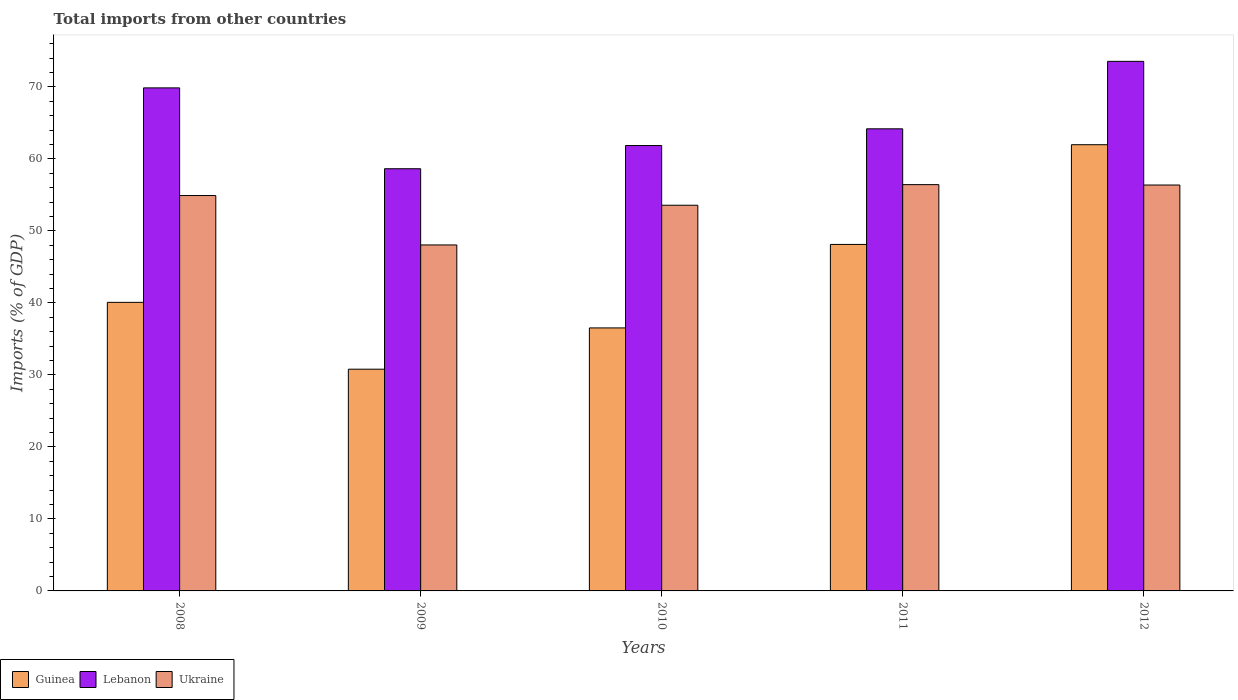How many different coloured bars are there?
Your answer should be very brief. 3. How many groups of bars are there?
Provide a short and direct response. 5. How many bars are there on the 4th tick from the right?
Give a very brief answer. 3. What is the label of the 5th group of bars from the left?
Give a very brief answer. 2012. In how many cases, is the number of bars for a given year not equal to the number of legend labels?
Keep it short and to the point. 0. What is the total imports in Lebanon in 2011?
Give a very brief answer. 64.18. Across all years, what is the maximum total imports in Guinea?
Your answer should be very brief. 61.97. Across all years, what is the minimum total imports in Guinea?
Your answer should be compact. 30.79. What is the total total imports in Guinea in the graph?
Your response must be concise. 217.49. What is the difference between the total imports in Guinea in 2008 and that in 2011?
Provide a succinct answer. -8.05. What is the difference between the total imports in Guinea in 2010 and the total imports in Lebanon in 2012?
Offer a very short reply. -37.02. What is the average total imports in Lebanon per year?
Keep it short and to the point. 65.62. In the year 2008, what is the difference between the total imports in Ukraine and total imports in Lebanon?
Your answer should be very brief. -14.95. In how many years, is the total imports in Ukraine greater than 58 %?
Your response must be concise. 0. What is the ratio of the total imports in Lebanon in 2009 to that in 2011?
Your answer should be very brief. 0.91. Is the difference between the total imports in Ukraine in 2009 and 2010 greater than the difference between the total imports in Lebanon in 2009 and 2010?
Your answer should be compact. No. What is the difference between the highest and the second highest total imports in Lebanon?
Ensure brevity in your answer.  3.69. What is the difference between the highest and the lowest total imports in Ukraine?
Your response must be concise. 8.38. In how many years, is the total imports in Ukraine greater than the average total imports in Ukraine taken over all years?
Provide a succinct answer. 3. What does the 3rd bar from the left in 2010 represents?
Your response must be concise. Ukraine. What does the 2nd bar from the right in 2009 represents?
Make the answer very short. Lebanon. Is it the case that in every year, the sum of the total imports in Lebanon and total imports in Ukraine is greater than the total imports in Guinea?
Provide a short and direct response. Yes. How many bars are there?
Your answer should be very brief. 15. Are all the bars in the graph horizontal?
Keep it short and to the point. No. Does the graph contain any zero values?
Make the answer very short. No. Does the graph contain grids?
Offer a very short reply. No. What is the title of the graph?
Offer a terse response. Total imports from other countries. What is the label or title of the X-axis?
Make the answer very short. Years. What is the label or title of the Y-axis?
Keep it short and to the point. Imports (% of GDP). What is the Imports (% of GDP) in Guinea in 2008?
Keep it short and to the point. 40.08. What is the Imports (% of GDP) in Lebanon in 2008?
Offer a very short reply. 69.86. What is the Imports (% of GDP) of Ukraine in 2008?
Keep it short and to the point. 54.91. What is the Imports (% of GDP) of Guinea in 2009?
Provide a succinct answer. 30.79. What is the Imports (% of GDP) of Lebanon in 2009?
Offer a very short reply. 58.63. What is the Imports (% of GDP) in Ukraine in 2009?
Keep it short and to the point. 48.05. What is the Imports (% of GDP) in Guinea in 2010?
Make the answer very short. 36.53. What is the Imports (% of GDP) of Lebanon in 2010?
Make the answer very short. 61.86. What is the Imports (% of GDP) in Ukraine in 2010?
Offer a terse response. 53.56. What is the Imports (% of GDP) of Guinea in 2011?
Make the answer very short. 48.12. What is the Imports (% of GDP) in Lebanon in 2011?
Ensure brevity in your answer.  64.18. What is the Imports (% of GDP) in Ukraine in 2011?
Your response must be concise. 56.43. What is the Imports (% of GDP) in Guinea in 2012?
Provide a short and direct response. 61.97. What is the Imports (% of GDP) in Lebanon in 2012?
Your answer should be compact. 73.55. What is the Imports (% of GDP) of Ukraine in 2012?
Give a very brief answer. 56.37. Across all years, what is the maximum Imports (% of GDP) of Guinea?
Your response must be concise. 61.97. Across all years, what is the maximum Imports (% of GDP) in Lebanon?
Keep it short and to the point. 73.55. Across all years, what is the maximum Imports (% of GDP) of Ukraine?
Your answer should be compact. 56.43. Across all years, what is the minimum Imports (% of GDP) in Guinea?
Keep it short and to the point. 30.79. Across all years, what is the minimum Imports (% of GDP) in Lebanon?
Ensure brevity in your answer.  58.63. Across all years, what is the minimum Imports (% of GDP) in Ukraine?
Offer a very short reply. 48.05. What is the total Imports (% of GDP) of Guinea in the graph?
Offer a terse response. 217.49. What is the total Imports (% of GDP) in Lebanon in the graph?
Give a very brief answer. 328.08. What is the total Imports (% of GDP) in Ukraine in the graph?
Provide a short and direct response. 269.32. What is the difference between the Imports (% of GDP) of Guinea in 2008 and that in 2009?
Your answer should be compact. 9.28. What is the difference between the Imports (% of GDP) in Lebanon in 2008 and that in 2009?
Your answer should be compact. 11.23. What is the difference between the Imports (% of GDP) in Ukraine in 2008 and that in 2009?
Your response must be concise. 6.86. What is the difference between the Imports (% of GDP) of Guinea in 2008 and that in 2010?
Give a very brief answer. 3.55. What is the difference between the Imports (% of GDP) in Lebanon in 2008 and that in 2010?
Your answer should be compact. 8.01. What is the difference between the Imports (% of GDP) in Ukraine in 2008 and that in 2010?
Your response must be concise. 1.35. What is the difference between the Imports (% of GDP) of Guinea in 2008 and that in 2011?
Your answer should be very brief. -8.05. What is the difference between the Imports (% of GDP) of Lebanon in 2008 and that in 2011?
Offer a very short reply. 5.68. What is the difference between the Imports (% of GDP) in Ukraine in 2008 and that in 2011?
Offer a very short reply. -1.51. What is the difference between the Imports (% of GDP) in Guinea in 2008 and that in 2012?
Provide a short and direct response. -21.89. What is the difference between the Imports (% of GDP) of Lebanon in 2008 and that in 2012?
Offer a terse response. -3.69. What is the difference between the Imports (% of GDP) of Ukraine in 2008 and that in 2012?
Your answer should be very brief. -1.46. What is the difference between the Imports (% of GDP) of Guinea in 2009 and that in 2010?
Your answer should be very brief. -5.73. What is the difference between the Imports (% of GDP) of Lebanon in 2009 and that in 2010?
Provide a short and direct response. -3.22. What is the difference between the Imports (% of GDP) in Ukraine in 2009 and that in 2010?
Your response must be concise. -5.51. What is the difference between the Imports (% of GDP) in Guinea in 2009 and that in 2011?
Provide a short and direct response. -17.33. What is the difference between the Imports (% of GDP) in Lebanon in 2009 and that in 2011?
Make the answer very short. -5.54. What is the difference between the Imports (% of GDP) in Ukraine in 2009 and that in 2011?
Offer a terse response. -8.38. What is the difference between the Imports (% of GDP) in Guinea in 2009 and that in 2012?
Provide a short and direct response. -31.18. What is the difference between the Imports (% of GDP) of Lebanon in 2009 and that in 2012?
Offer a terse response. -14.91. What is the difference between the Imports (% of GDP) of Ukraine in 2009 and that in 2012?
Make the answer very short. -8.32. What is the difference between the Imports (% of GDP) in Guinea in 2010 and that in 2011?
Keep it short and to the point. -11.59. What is the difference between the Imports (% of GDP) of Lebanon in 2010 and that in 2011?
Your answer should be compact. -2.32. What is the difference between the Imports (% of GDP) of Ukraine in 2010 and that in 2011?
Keep it short and to the point. -2.86. What is the difference between the Imports (% of GDP) of Guinea in 2010 and that in 2012?
Keep it short and to the point. -25.44. What is the difference between the Imports (% of GDP) in Lebanon in 2010 and that in 2012?
Provide a short and direct response. -11.69. What is the difference between the Imports (% of GDP) in Ukraine in 2010 and that in 2012?
Provide a succinct answer. -2.81. What is the difference between the Imports (% of GDP) in Guinea in 2011 and that in 2012?
Provide a succinct answer. -13.85. What is the difference between the Imports (% of GDP) in Lebanon in 2011 and that in 2012?
Your answer should be compact. -9.37. What is the difference between the Imports (% of GDP) of Ukraine in 2011 and that in 2012?
Offer a terse response. 0.05. What is the difference between the Imports (% of GDP) of Guinea in 2008 and the Imports (% of GDP) of Lebanon in 2009?
Offer a very short reply. -18.56. What is the difference between the Imports (% of GDP) in Guinea in 2008 and the Imports (% of GDP) in Ukraine in 2009?
Your answer should be very brief. -7.97. What is the difference between the Imports (% of GDP) of Lebanon in 2008 and the Imports (% of GDP) of Ukraine in 2009?
Make the answer very short. 21.81. What is the difference between the Imports (% of GDP) in Guinea in 2008 and the Imports (% of GDP) in Lebanon in 2010?
Provide a short and direct response. -21.78. What is the difference between the Imports (% of GDP) of Guinea in 2008 and the Imports (% of GDP) of Ukraine in 2010?
Your answer should be compact. -13.49. What is the difference between the Imports (% of GDP) in Lebanon in 2008 and the Imports (% of GDP) in Ukraine in 2010?
Your answer should be compact. 16.3. What is the difference between the Imports (% of GDP) in Guinea in 2008 and the Imports (% of GDP) in Lebanon in 2011?
Offer a very short reply. -24.1. What is the difference between the Imports (% of GDP) in Guinea in 2008 and the Imports (% of GDP) in Ukraine in 2011?
Give a very brief answer. -16.35. What is the difference between the Imports (% of GDP) of Lebanon in 2008 and the Imports (% of GDP) of Ukraine in 2011?
Give a very brief answer. 13.44. What is the difference between the Imports (% of GDP) of Guinea in 2008 and the Imports (% of GDP) of Lebanon in 2012?
Keep it short and to the point. -33.47. What is the difference between the Imports (% of GDP) in Guinea in 2008 and the Imports (% of GDP) in Ukraine in 2012?
Your response must be concise. -16.3. What is the difference between the Imports (% of GDP) of Lebanon in 2008 and the Imports (% of GDP) of Ukraine in 2012?
Your response must be concise. 13.49. What is the difference between the Imports (% of GDP) of Guinea in 2009 and the Imports (% of GDP) of Lebanon in 2010?
Provide a short and direct response. -31.06. What is the difference between the Imports (% of GDP) of Guinea in 2009 and the Imports (% of GDP) of Ukraine in 2010?
Your response must be concise. -22.77. What is the difference between the Imports (% of GDP) in Lebanon in 2009 and the Imports (% of GDP) in Ukraine in 2010?
Ensure brevity in your answer.  5.07. What is the difference between the Imports (% of GDP) of Guinea in 2009 and the Imports (% of GDP) of Lebanon in 2011?
Give a very brief answer. -33.39. What is the difference between the Imports (% of GDP) in Guinea in 2009 and the Imports (% of GDP) in Ukraine in 2011?
Offer a very short reply. -25.63. What is the difference between the Imports (% of GDP) in Lebanon in 2009 and the Imports (% of GDP) in Ukraine in 2011?
Provide a short and direct response. 2.21. What is the difference between the Imports (% of GDP) in Guinea in 2009 and the Imports (% of GDP) in Lebanon in 2012?
Offer a very short reply. -42.75. What is the difference between the Imports (% of GDP) in Guinea in 2009 and the Imports (% of GDP) in Ukraine in 2012?
Give a very brief answer. -25.58. What is the difference between the Imports (% of GDP) in Lebanon in 2009 and the Imports (% of GDP) in Ukraine in 2012?
Offer a very short reply. 2.26. What is the difference between the Imports (% of GDP) of Guinea in 2010 and the Imports (% of GDP) of Lebanon in 2011?
Keep it short and to the point. -27.65. What is the difference between the Imports (% of GDP) in Guinea in 2010 and the Imports (% of GDP) in Ukraine in 2011?
Make the answer very short. -19.9. What is the difference between the Imports (% of GDP) of Lebanon in 2010 and the Imports (% of GDP) of Ukraine in 2011?
Keep it short and to the point. 5.43. What is the difference between the Imports (% of GDP) of Guinea in 2010 and the Imports (% of GDP) of Lebanon in 2012?
Offer a very short reply. -37.02. What is the difference between the Imports (% of GDP) in Guinea in 2010 and the Imports (% of GDP) in Ukraine in 2012?
Give a very brief answer. -19.84. What is the difference between the Imports (% of GDP) of Lebanon in 2010 and the Imports (% of GDP) of Ukraine in 2012?
Your answer should be very brief. 5.48. What is the difference between the Imports (% of GDP) in Guinea in 2011 and the Imports (% of GDP) in Lebanon in 2012?
Give a very brief answer. -25.43. What is the difference between the Imports (% of GDP) in Guinea in 2011 and the Imports (% of GDP) in Ukraine in 2012?
Keep it short and to the point. -8.25. What is the difference between the Imports (% of GDP) in Lebanon in 2011 and the Imports (% of GDP) in Ukraine in 2012?
Ensure brevity in your answer.  7.81. What is the average Imports (% of GDP) in Guinea per year?
Make the answer very short. 43.5. What is the average Imports (% of GDP) in Lebanon per year?
Make the answer very short. 65.62. What is the average Imports (% of GDP) of Ukraine per year?
Offer a terse response. 53.86. In the year 2008, what is the difference between the Imports (% of GDP) of Guinea and Imports (% of GDP) of Lebanon?
Offer a terse response. -29.79. In the year 2008, what is the difference between the Imports (% of GDP) in Guinea and Imports (% of GDP) in Ukraine?
Provide a short and direct response. -14.83. In the year 2008, what is the difference between the Imports (% of GDP) in Lebanon and Imports (% of GDP) in Ukraine?
Your answer should be very brief. 14.95. In the year 2009, what is the difference between the Imports (% of GDP) of Guinea and Imports (% of GDP) of Lebanon?
Provide a short and direct response. -27.84. In the year 2009, what is the difference between the Imports (% of GDP) in Guinea and Imports (% of GDP) in Ukraine?
Provide a succinct answer. -17.26. In the year 2009, what is the difference between the Imports (% of GDP) of Lebanon and Imports (% of GDP) of Ukraine?
Your answer should be very brief. 10.58. In the year 2010, what is the difference between the Imports (% of GDP) in Guinea and Imports (% of GDP) in Lebanon?
Keep it short and to the point. -25.33. In the year 2010, what is the difference between the Imports (% of GDP) in Guinea and Imports (% of GDP) in Ukraine?
Make the answer very short. -17.04. In the year 2010, what is the difference between the Imports (% of GDP) of Lebanon and Imports (% of GDP) of Ukraine?
Keep it short and to the point. 8.29. In the year 2011, what is the difference between the Imports (% of GDP) of Guinea and Imports (% of GDP) of Lebanon?
Ensure brevity in your answer.  -16.06. In the year 2011, what is the difference between the Imports (% of GDP) in Guinea and Imports (% of GDP) in Ukraine?
Make the answer very short. -8.3. In the year 2011, what is the difference between the Imports (% of GDP) in Lebanon and Imports (% of GDP) in Ukraine?
Provide a succinct answer. 7.75. In the year 2012, what is the difference between the Imports (% of GDP) in Guinea and Imports (% of GDP) in Lebanon?
Your response must be concise. -11.58. In the year 2012, what is the difference between the Imports (% of GDP) of Guinea and Imports (% of GDP) of Ukraine?
Offer a terse response. 5.6. In the year 2012, what is the difference between the Imports (% of GDP) in Lebanon and Imports (% of GDP) in Ukraine?
Your answer should be very brief. 17.18. What is the ratio of the Imports (% of GDP) of Guinea in 2008 to that in 2009?
Offer a very short reply. 1.3. What is the ratio of the Imports (% of GDP) of Lebanon in 2008 to that in 2009?
Keep it short and to the point. 1.19. What is the ratio of the Imports (% of GDP) in Ukraine in 2008 to that in 2009?
Your answer should be very brief. 1.14. What is the ratio of the Imports (% of GDP) in Guinea in 2008 to that in 2010?
Ensure brevity in your answer.  1.1. What is the ratio of the Imports (% of GDP) of Lebanon in 2008 to that in 2010?
Your response must be concise. 1.13. What is the ratio of the Imports (% of GDP) in Ukraine in 2008 to that in 2010?
Make the answer very short. 1.03. What is the ratio of the Imports (% of GDP) in Guinea in 2008 to that in 2011?
Keep it short and to the point. 0.83. What is the ratio of the Imports (% of GDP) in Lebanon in 2008 to that in 2011?
Provide a succinct answer. 1.09. What is the ratio of the Imports (% of GDP) of Ukraine in 2008 to that in 2011?
Offer a terse response. 0.97. What is the ratio of the Imports (% of GDP) of Guinea in 2008 to that in 2012?
Give a very brief answer. 0.65. What is the ratio of the Imports (% of GDP) of Lebanon in 2008 to that in 2012?
Offer a very short reply. 0.95. What is the ratio of the Imports (% of GDP) of Ukraine in 2008 to that in 2012?
Offer a very short reply. 0.97. What is the ratio of the Imports (% of GDP) in Guinea in 2009 to that in 2010?
Provide a succinct answer. 0.84. What is the ratio of the Imports (% of GDP) in Lebanon in 2009 to that in 2010?
Give a very brief answer. 0.95. What is the ratio of the Imports (% of GDP) in Ukraine in 2009 to that in 2010?
Ensure brevity in your answer.  0.9. What is the ratio of the Imports (% of GDP) of Guinea in 2009 to that in 2011?
Ensure brevity in your answer.  0.64. What is the ratio of the Imports (% of GDP) in Lebanon in 2009 to that in 2011?
Give a very brief answer. 0.91. What is the ratio of the Imports (% of GDP) in Ukraine in 2009 to that in 2011?
Make the answer very short. 0.85. What is the ratio of the Imports (% of GDP) of Guinea in 2009 to that in 2012?
Offer a very short reply. 0.5. What is the ratio of the Imports (% of GDP) of Lebanon in 2009 to that in 2012?
Give a very brief answer. 0.8. What is the ratio of the Imports (% of GDP) in Ukraine in 2009 to that in 2012?
Keep it short and to the point. 0.85. What is the ratio of the Imports (% of GDP) of Guinea in 2010 to that in 2011?
Offer a very short reply. 0.76. What is the ratio of the Imports (% of GDP) in Lebanon in 2010 to that in 2011?
Give a very brief answer. 0.96. What is the ratio of the Imports (% of GDP) of Ukraine in 2010 to that in 2011?
Your response must be concise. 0.95. What is the ratio of the Imports (% of GDP) in Guinea in 2010 to that in 2012?
Provide a short and direct response. 0.59. What is the ratio of the Imports (% of GDP) in Lebanon in 2010 to that in 2012?
Provide a succinct answer. 0.84. What is the ratio of the Imports (% of GDP) of Ukraine in 2010 to that in 2012?
Give a very brief answer. 0.95. What is the ratio of the Imports (% of GDP) in Guinea in 2011 to that in 2012?
Offer a very short reply. 0.78. What is the ratio of the Imports (% of GDP) of Lebanon in 2011 to that in 2012?
Offer a terse response. 0.87. What is the difference between the highest and the second highest Imports (% of GDP) in Guinea?
Provide a succinct answer. 13.85. What is the difference between the highest and the second highest Imports (% of GDP) of Lebanon?
Give a very brief answer. 3.69. What is the difference between the highest and the second highest Imports (% of GDP) of Ukraine?
Your answer should be very brief. 0.05. What is the difference between the highest and the lowest Imports (% of GDP) of Guinea?
Offer a terse response. 31.18. What is the difference between the highest and the lowest Imports (% of GDP) in Lebanon?
Provide a short and direct response. 14.91. What is the difference between the highest and the lowest Imports (% of GDP) in Ukraine?
Your answer should be compact. 8.38. 